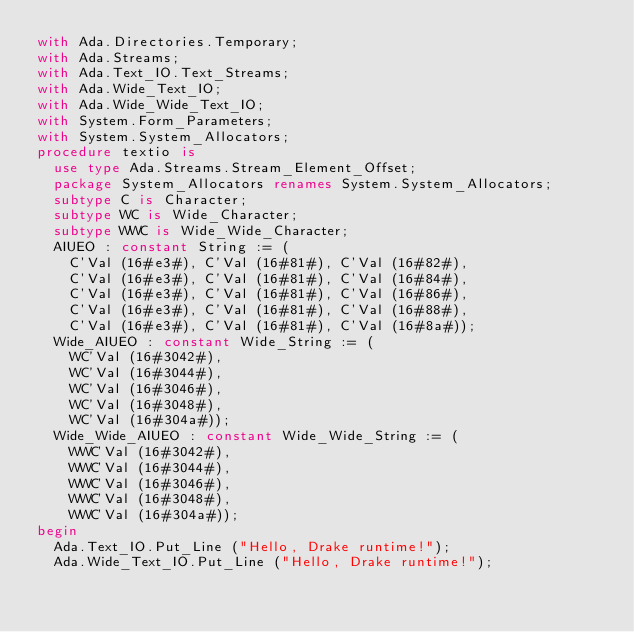Convert code to text. <code><loc_0><loc_0><loc_500><loc_500><_Ada_>with Ada.Directories.Temporary;
with Ada.Streams;
with Ada.Text_IO.Text_Streams;
with Ada.Wide_Text_IO;
with Ada.Wide_Wide_Text_IO;
with System.Form_Parameters;
with System.System_Allocators;
procedure textio is
	use type Ada.Streams.Stream_Element_Offset;
	package System_Allocators renames System.System_Allocators;
	subtype C is Character;
	subtype WC is Wide_Character;
	subtype WWC is Wide_Wide_Character;
	AIUEO : constant String := (
		C'Val (16#e3#), C'Val (16#81#), C'Val (16#82#),
		C'Val (16#e3#), C'Val (16#81#), C'Val (16#84#),
		C'Val (16#e3#), C'Val (16#81#), C'Val (16#86#),
		C'Val (16#e3#), C'Val (16#81#), C'Val (16#88#),
		C'Val (16#e3#), C'Val (16#81#), C'Val (16#8a#));
	Wide_AIUEO : constant Wide_String := (
		WC'Val (16#3042#),
		WC'Val (16#3044#),
		WC'Val (16#3046#),
		WC'Val (16#3048#),
		WC'Val (16#304a#));
	Wide_Wide_AIUEO : constant Wide_Wide_String := (
		WWC'Val (16#3042#),
		WWC'Val (16#3044#),
		WWC'Val (16#3046#),
		WWC'Val (16#3048#),
		WWC'Val (16#304a#));
begin
	Ada.Text_IO.Put_Line ("Hello, Drake runtime!");
	Ada.Wide_Text_IO.Put_Line ("Hello, Drake runtime!");</code> 